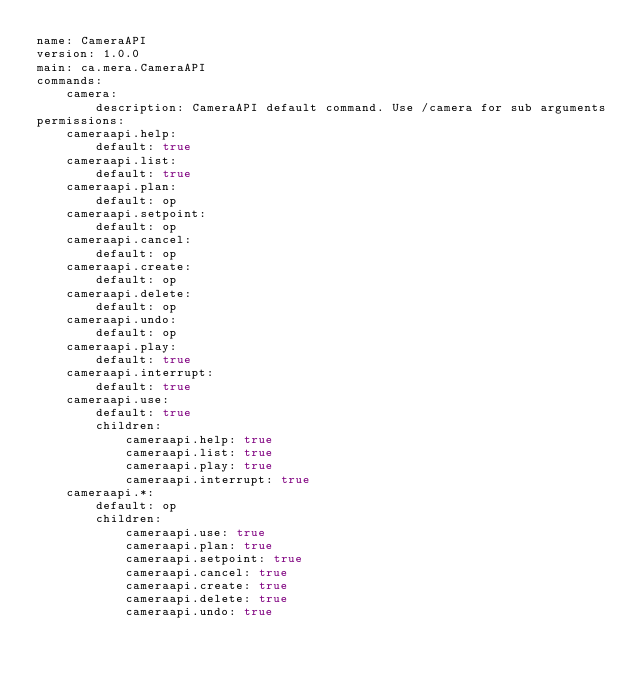Convert code to text. <code><loc_0><loc_0><loc_500><loc_500><_YAML_>name: CameraAPI
version: 1.0.0
main: ca.mera.CameraAPI
commands:
    camera:
        description: CameraAPI default command. Use /camera for sub arguments
permissions:
    cameraapi.help:
        default: true
    cameraapi.list:
        default: true
    cameraapi.plan:
        default: op
    cameraapi.setpoint:
        default: op
    cameraapi.cancel:
        default: op
    cameraapi.create:
        default: op
    cameraapi.delete:
        default: op
    cameraapi.undo:
        default: op
    cameraapi.play:
        default: true
    cameraapi.interrupt:
        default: true
    cameraapi.use:
        default: true
        children:
            cameraapi.help: true
            cameraapi.list: true
            cameraapi.play: true
            cameraapi.interrupt: true
    cameraapi.*:
        default: op
        children:
            cameraapi.use: true
            cameraapi.plan: true
            cameraapi.setpoint: true
            cameraapi.cancel: true
            cameraapi.create: true
            cameraapi.delete: true
            cameraapi.undo: true</code> 